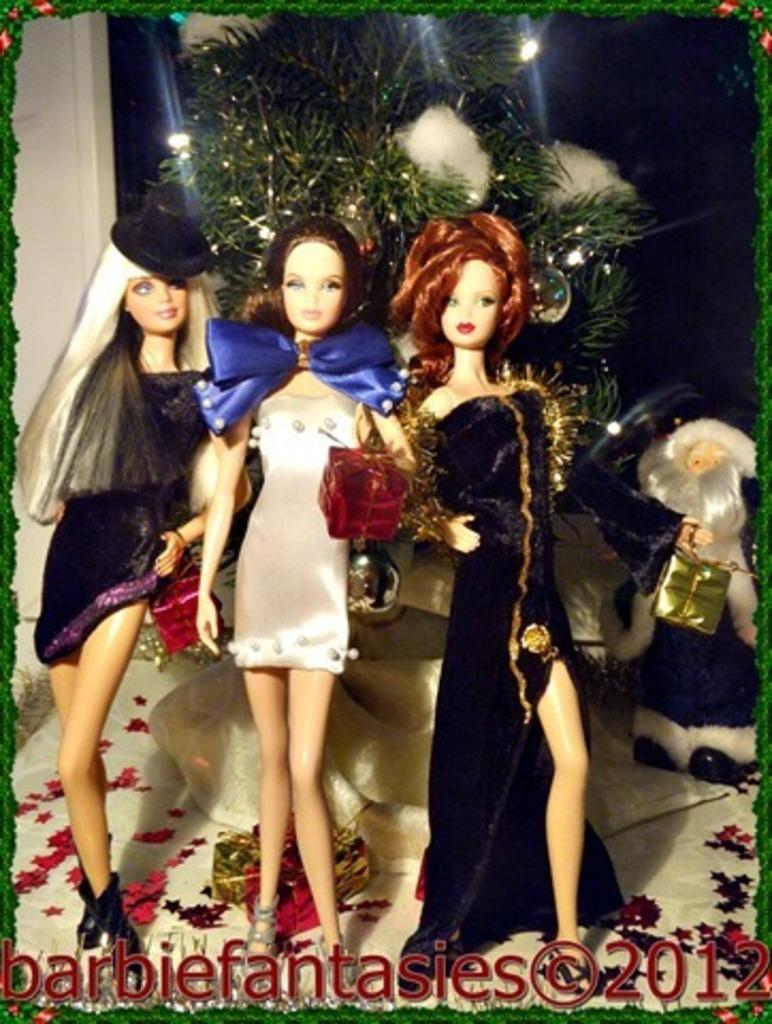How many Barbie dolls are present in the image? There are three Barbie dolls in the image. What are the Barbie dolls holding in their hands? The Barbie dolls are holding presents. What can be seen in the background of the image? There is an Xmas tree in the background of the image. Is there any text or marking at the bottom of the image? Yes, there is a watermark at the bottom of the image. What type of rock can be seen being adjusted by the Barbie dolls in the image? There is no rock present in the image, and the Barbie dolls are not shown adjusting anything. 